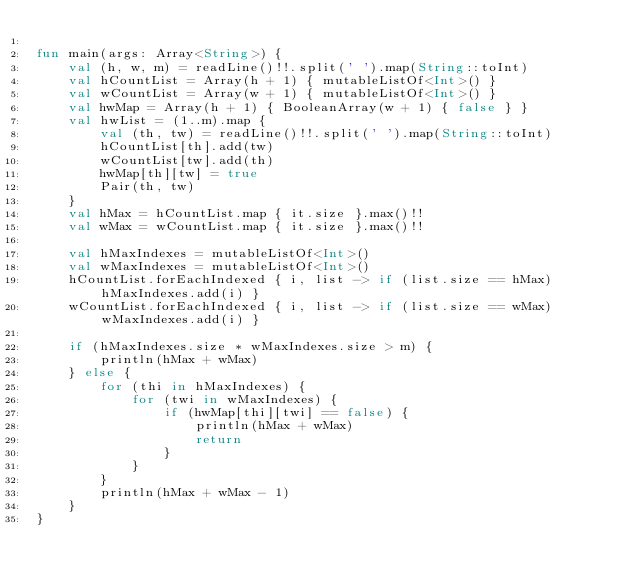<code> <loc_0><loc_0><loc_500><loc_500><_Kotlin_>
fun main(args: Array<String>) {
    val (h, w, m) = readLine()!!.split(' ').map(String::toInt)
    val hCountList = Array(h + 1) { mutableListOf<Int>() }
    val wCountList = Array(w + 1) { mutableListOf<Int>() }
    val hwMap = Array(h + 1) { BooleanArray(w + 1) { false } }
    val hwList = (1..m).map {
        val (th, tw) = readLine()!!.split(' ').map(String::toInt)
        hCountList[th].add(tw)
        wCountList[tw].add(th)
        hwMap[th][tw] = true
        Pair(th, tw)
    }
    val hMax = hCountList.map { it.size }.max()!!
    val wMax = wCountList.map { it.size }.max()!!

    val hMaxIndexes = mutableListOf<Int>()
    val wMaxIndexes = mutableListOf<Int>()
    hCountList.forEachIndexed { i, list -> if (list.size == hMax) hMaxIndexes.add(i) }
    wCountList.forEachIndexed { i, list -> if (list.size == wMax) wMaxIndexes.add(i) }

    if (hMaxIndexes.size * wMaxIndexes.size > m) {
        println(hMax + wMax)
    } else {
        for (thi in hMaxIndexes) {
            for (twi in wMaxIndexes) {
                if (hwMap[thi][twi] == false) {
                    println(hMax + wMax)
                    return
                }
            }
        }
        println(hMax + wMax - 1)
    }
}
</code> 